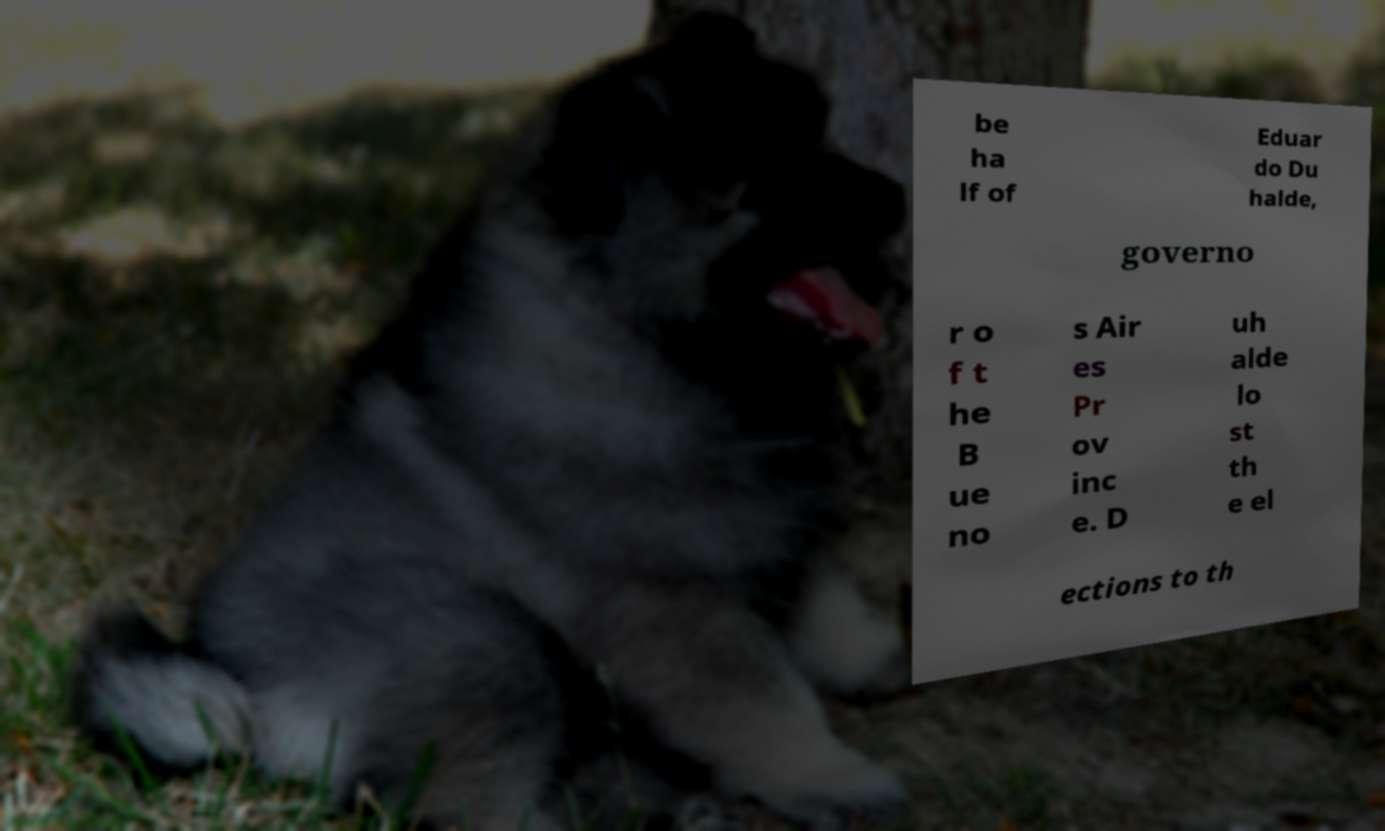What messages or text are displayed in this image? I need them in a readable, typed format. be ha lf of Eduar do Du halde, governo r o f t he B ue no s Air es Pr ov inc e. D uh alde lo st th e el ections to th 